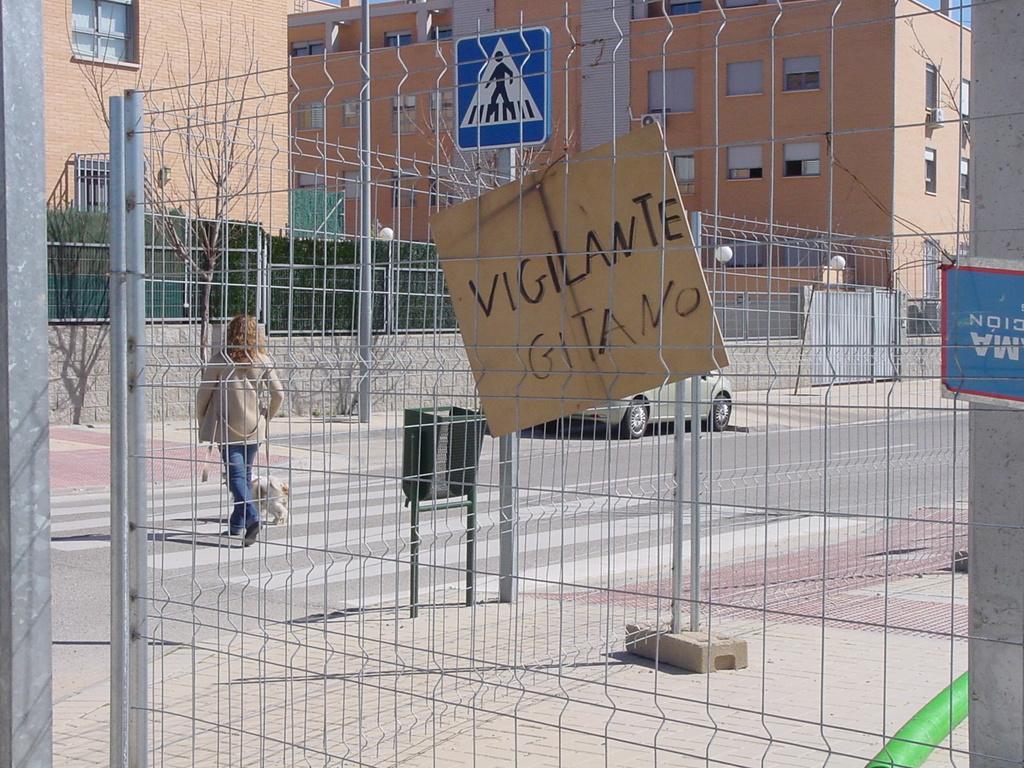Describe this image in one or two sentences. In this picture, we can see a person with dog, road, vehicle, poles, fencing, the wall, boards, with some text, and we can see sign boards, fencing, buildings, and some objects attached to it, trees, and the sky. 